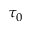<formula> <loc_0><loc_0><loc_500><loc_500>\tau _ { 0 }</formula> 